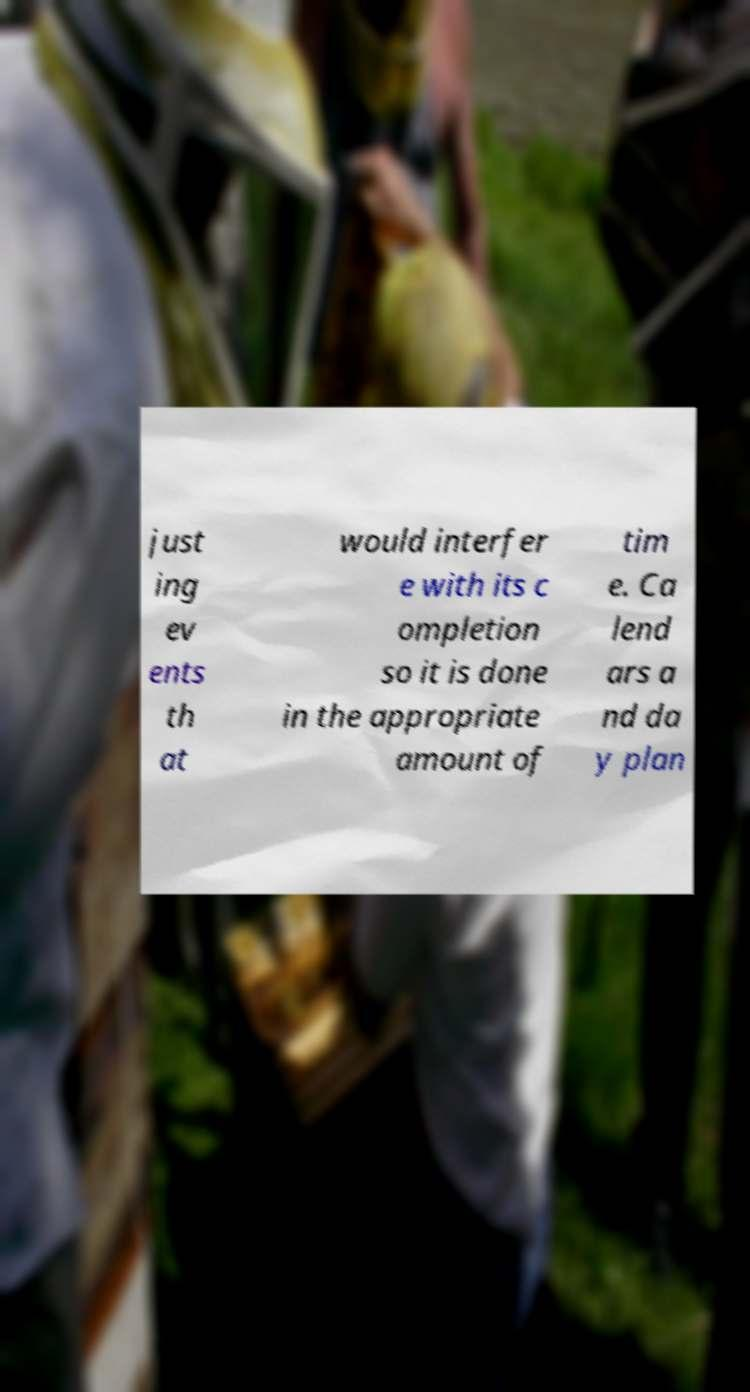There's text embedded in this image that I need extracted. Can you transcribe it verbatim? just ing ev ents th at would interfer e with its c ompletion so it is done in the appropriate amount of tim e. Ca lend ars a nd da y plan 